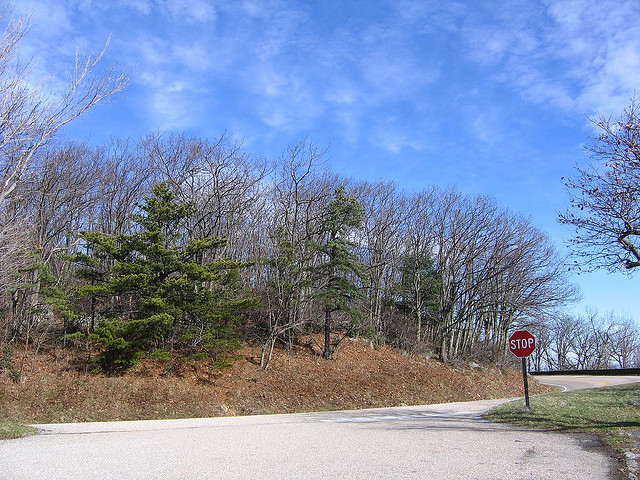Is it Shady? There are no significant shadows or shaded areas visible in the image, indicating that it is not shady. 